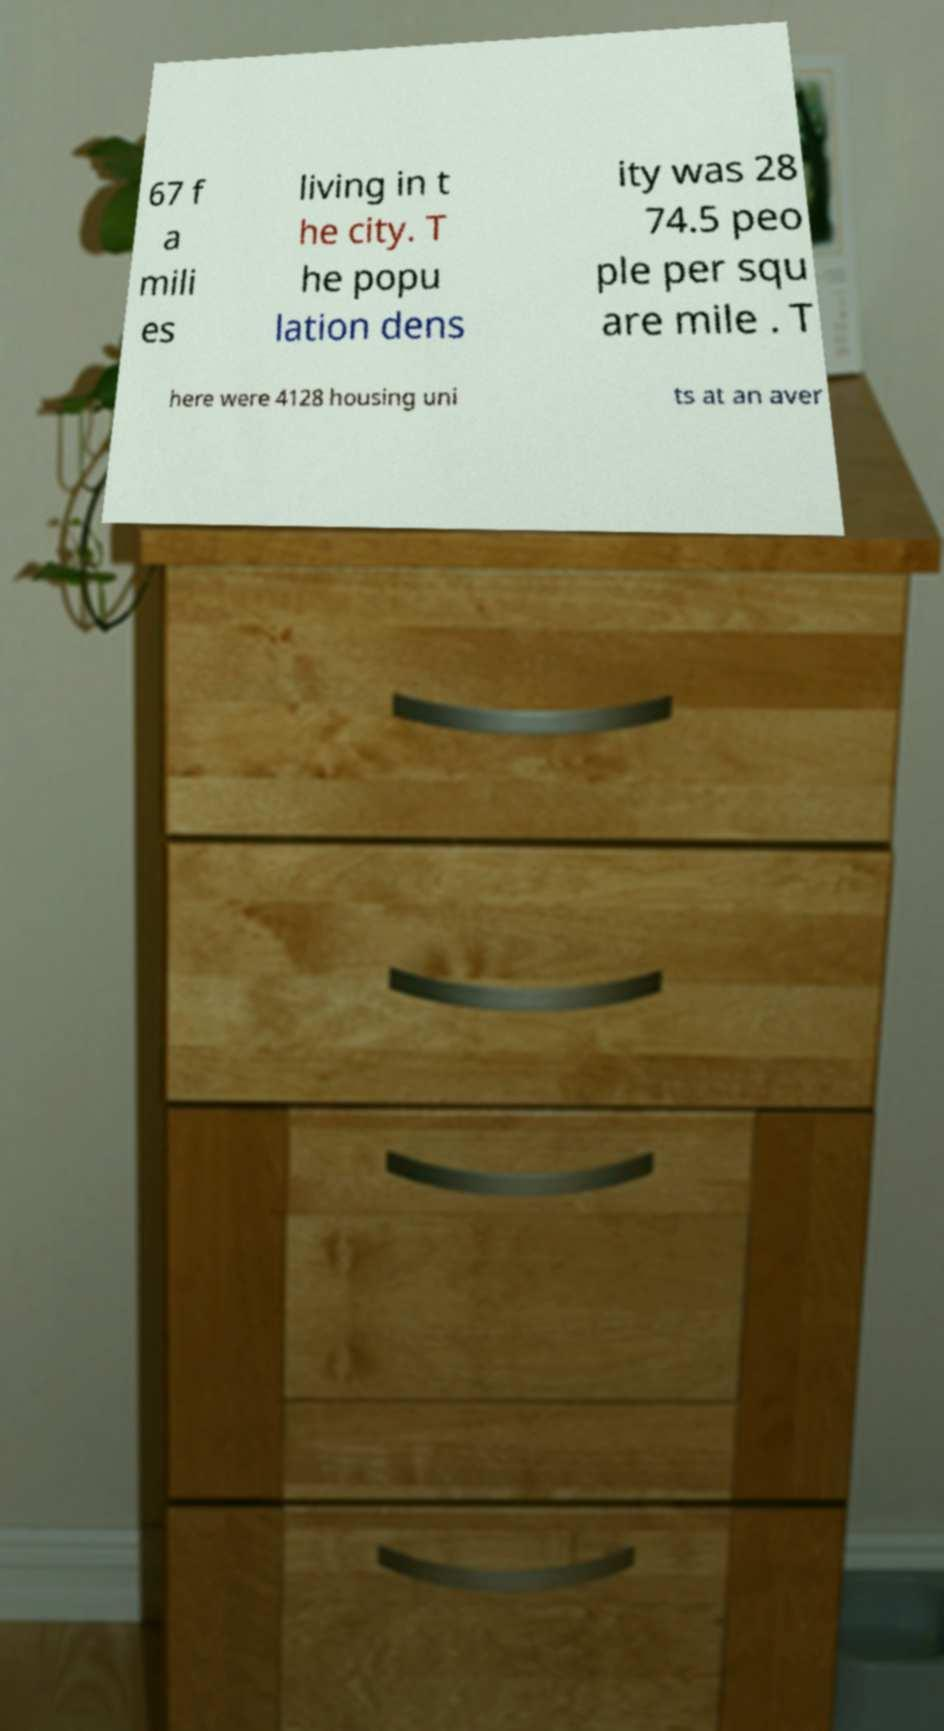Please identify and transcribe the text found in this image. 67 f a mili es living in t he city. T he popu lation dens ity was 28 74.5 peo ple per squ are mile . T here were 4128 housing uni ts at an aver 